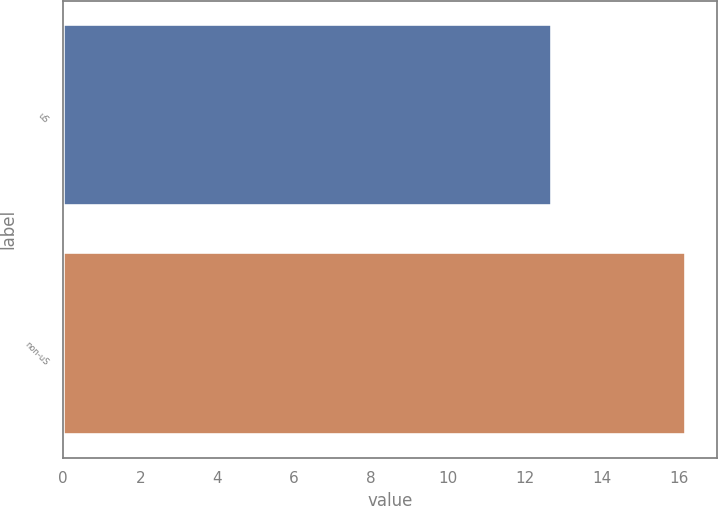<chart> <loc_0><loc_0><loc_500><loc_500><bar_chart><fcel>uS<fcel>non-uS<nl><fcel>12.7<fcel>16.2<nl></chart> 